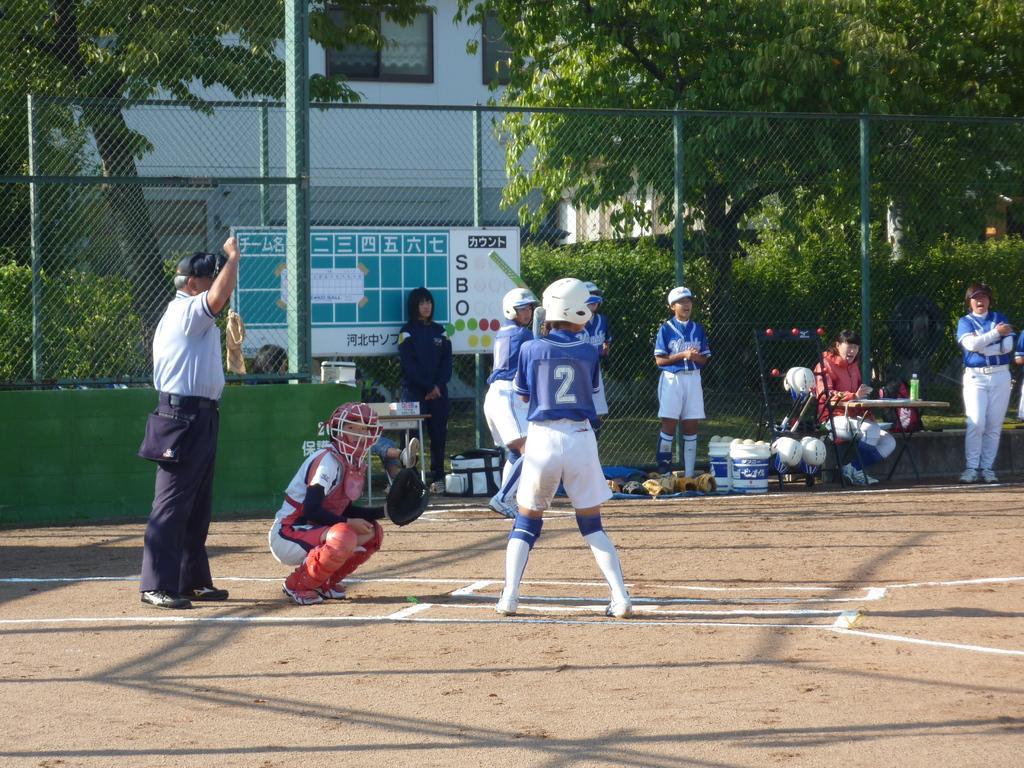Could you give a brief overview of what you see in this image? In this image there are a few people standing on the ground and there are few objects, beside the objects there is a lady sitting. In the background there is a net fence and a banner attached to it, trees and a building. 